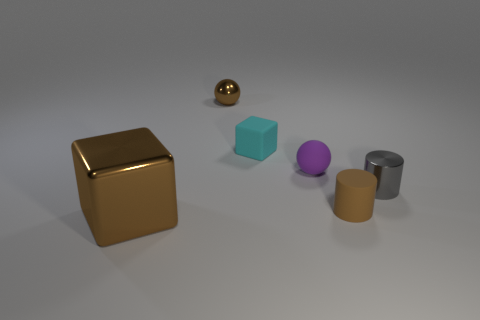There is another small thing that is the same shape as the gray thing; what is its material?
Provide a succinct answer. Rubber. Are the brown sphere and the cyan thing made of the same material?
Offer a very short reply. No. What color is the sphere on the right side of the small metallic object that is left of the small matte block?
Offer a very short reply. Purple. The gray cylinder that is made of the same material as the brown ball is what size?
Offer a very short reply. Small. How many cyan matte objects have the same shape as the brown matte object?
Provide a short and direct response. 0. How many things are small metallic things to the right of the purple sphere or cubes behind the brown block?
Your answer should be compact. 2. What number of rubber blocks are in front of the big brown block in front of the purple matte thing?
Your response must be concise. 0. There is a tiny object that is in front of the tiny gray metal cylinder; is its shape the same as the thing on the left side of the shiny sphere?
Provide a succinct answer. No. There is a tiny object that is the same color as the small matte cylinder; what shape is it?
Your response must be concise. Sphere. Are there any tiny gray things that have the same material as the large object?
Your answer should be compact. Yes. 